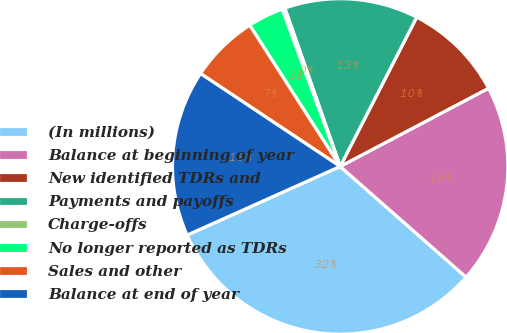<chart> <loc_0><loc_0><loc_500><loc_500><pie_chart><fcel>(In millions)<fcel>Balance at beginning of year<fcel>New identified TDRs and<fcel>Payments and payoffs<fcel>Charge-offs<fcel>No longer reported as TDRs<fcel>Sales and other<fcel>Balance at end of year<nl><fcel>31.81%<fcel>19.2%<fcel>9.74%<fcel>12.89%<fcel>0.28%<fcel>3.44%<fcel>6.59%<fcel>16.05%<nl></chart> 